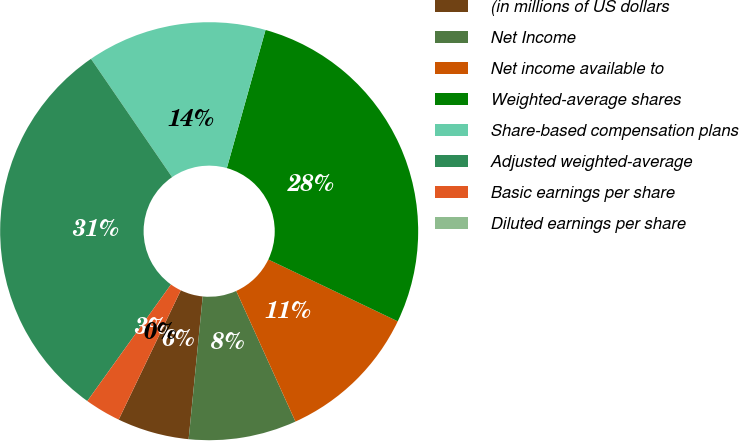Convert chart to OTSL. <chart><loc_0><loc_0><loc_500><loc_500><pie_chart><fcel>(in millions of US dollars<fcel>Net Income<fcel>Net income available to<fcel>Weighted-average shares<fcel>Share-based compensation plans<fcel>Adjusted weighted-average<fcel>Basic earnings per share<fcel>Diluted earnings per share<nl><fcel>5.56%<fcel>8.34%<fcel>11.13%<fcel>27.75%<fcel>13.91%<fcel>30.53%<fcel>2.78%<fcel>0.0%<nl></chart> 